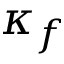Convert formula to latex. <formula><loc_0><loc_0><loc_500><loc_500>\kappa _ { f }</formula> 